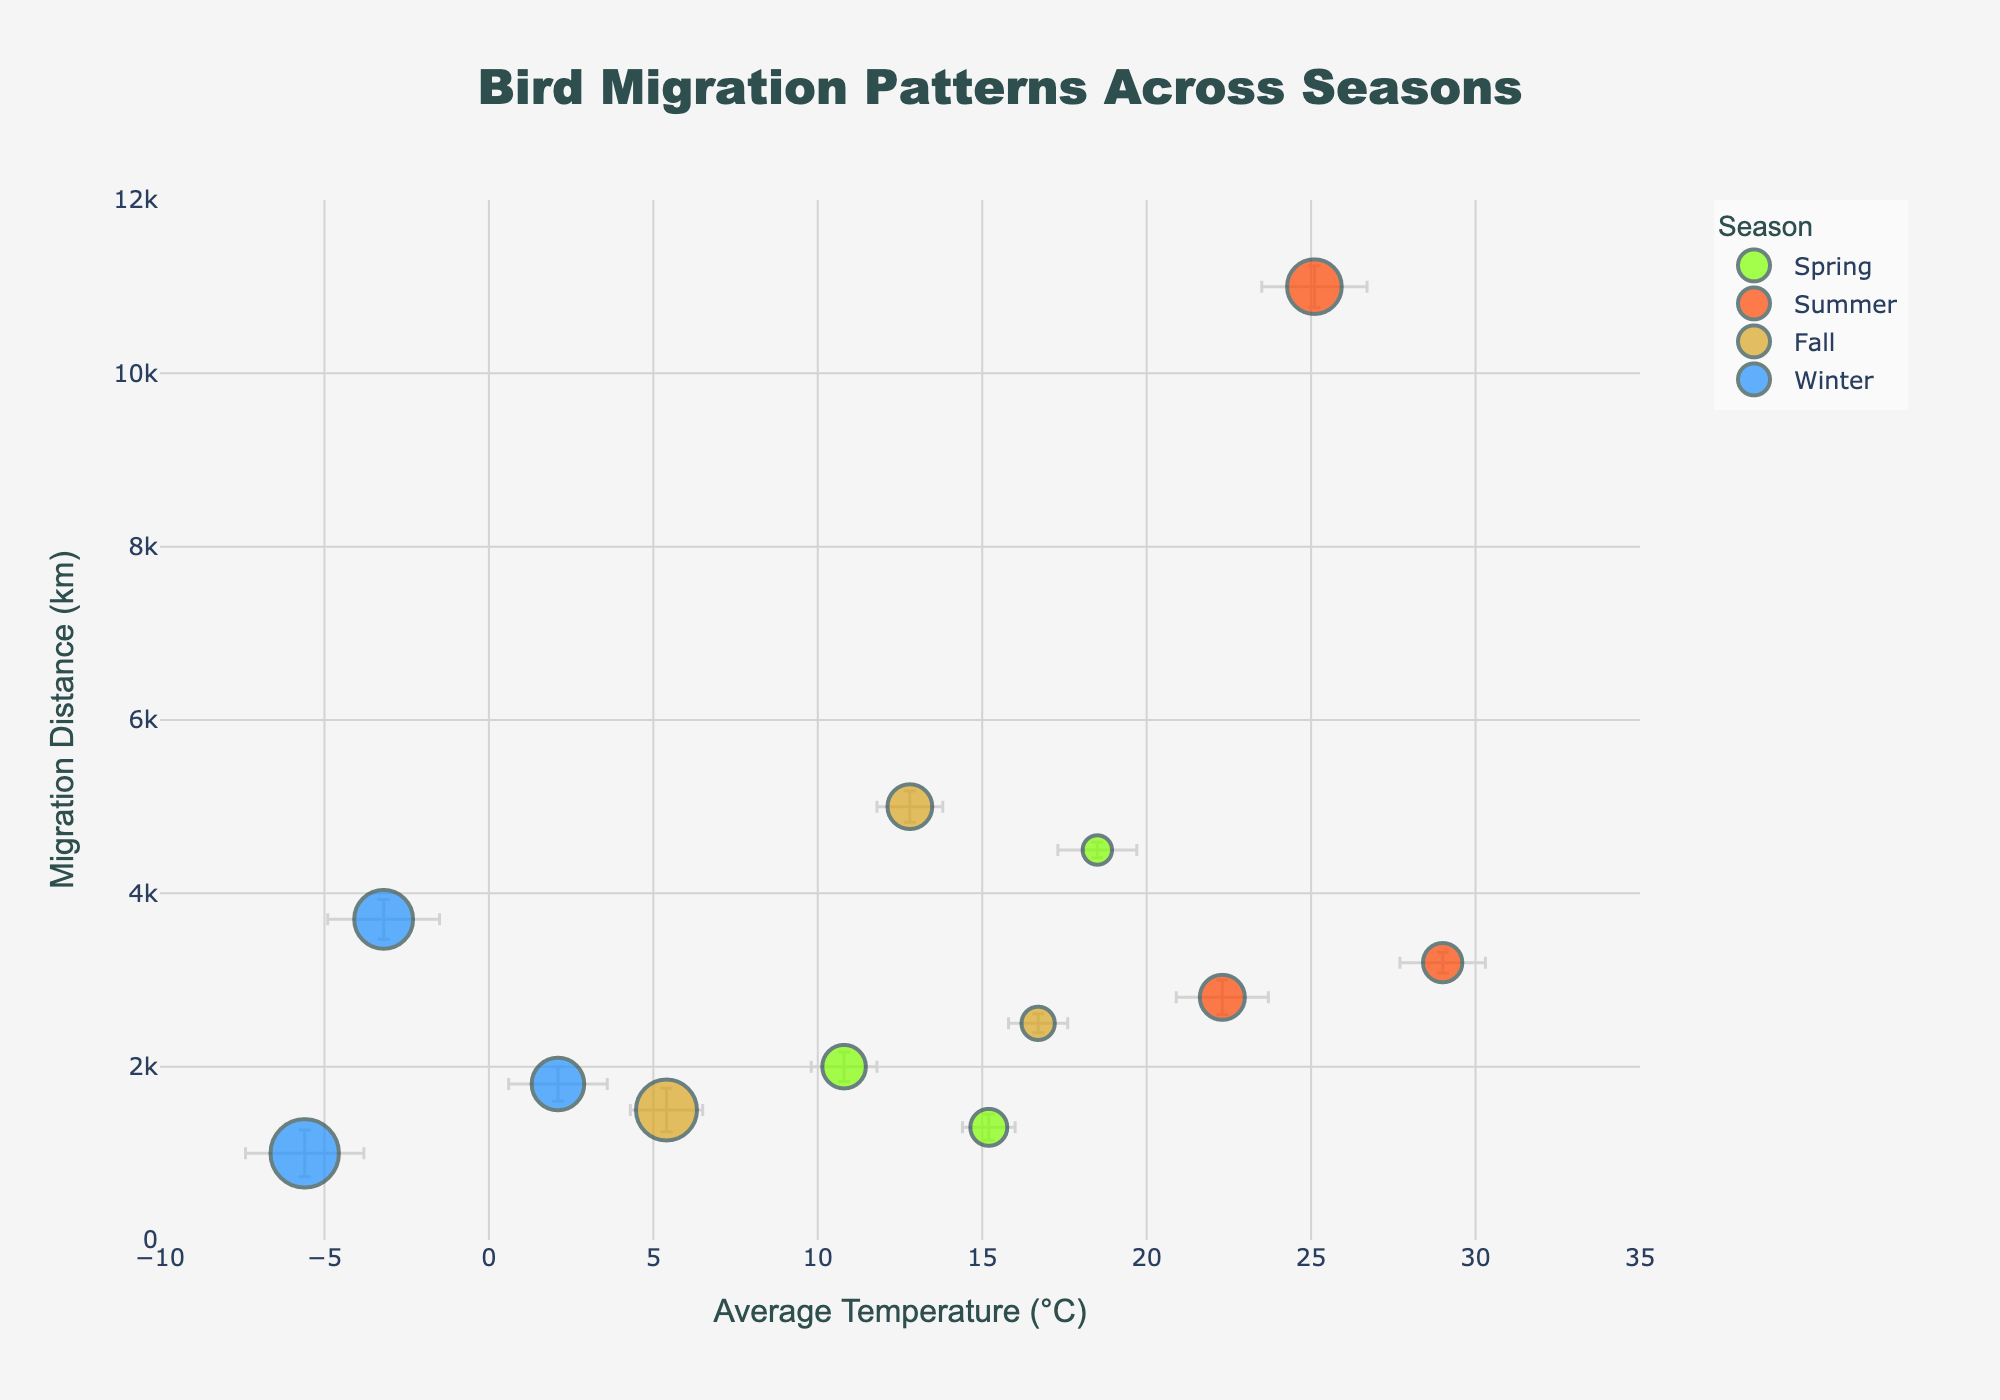What's the title of the figure? Look at the top of the figure where the bold text is displayed.
Answer: Bird Migration Patterns Across Seasons How many bird species are shown for the Spring season? Identify the markers belonging to the Spring season, represented by the green color. Count the number of these markers.
Answer: 3 Which bird species has the highest migration distance in the Summer? Locate the Summer season markers, shown in orange, and identify the bird species with the highest y-axis value.
Answer: Bar-tailed Godwit Does the Fall season generally have higher or lower average temperatures compared to Winter? Compare the x-axis positions of the Fall (golden markers) and Winter (blue markers) points.
Answer: Higher Which season has the bird species with the highest wind speed? Look for the season with markers that have the largest sizes, as marker size indicates wind speed.
Answer: Winter What is the migration distance difference between the Swainson's Thrush and the Snowy Owl? Locate the markers for Swainson's Thrush and Snowy Owl. Subtract their y-axis values.
Answer: 3000 km Which bird species experienced the lowest average temperature? Identify the bird species corresponding to the lowest x-axis value.
Answer: Common Eider In which season do bird species display the largest temperature error bars? Compare the lengths of the horizontal error bars for each season's markers.
Answer: Winter By how many kilometers does the migration distance of the Blackpoll Warbler exceed that of the Common Starling? Find the y-axis values for Blackpoll Warbler and Common Starling. Subtract the lower value from the higher value.
Answer: 3700 km Which two bird species in the Summer have similar average temperatures but different migration distances? Look for orange markers that are close together on the x-axis but far apart on the y-axis.
Answer: Bar-tailed Godwit and Ruby-throated Hummingbird 